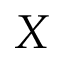Convert formula to latex. <formula><loc_0><loc_0><loc_500><loc_500>X</formula> 